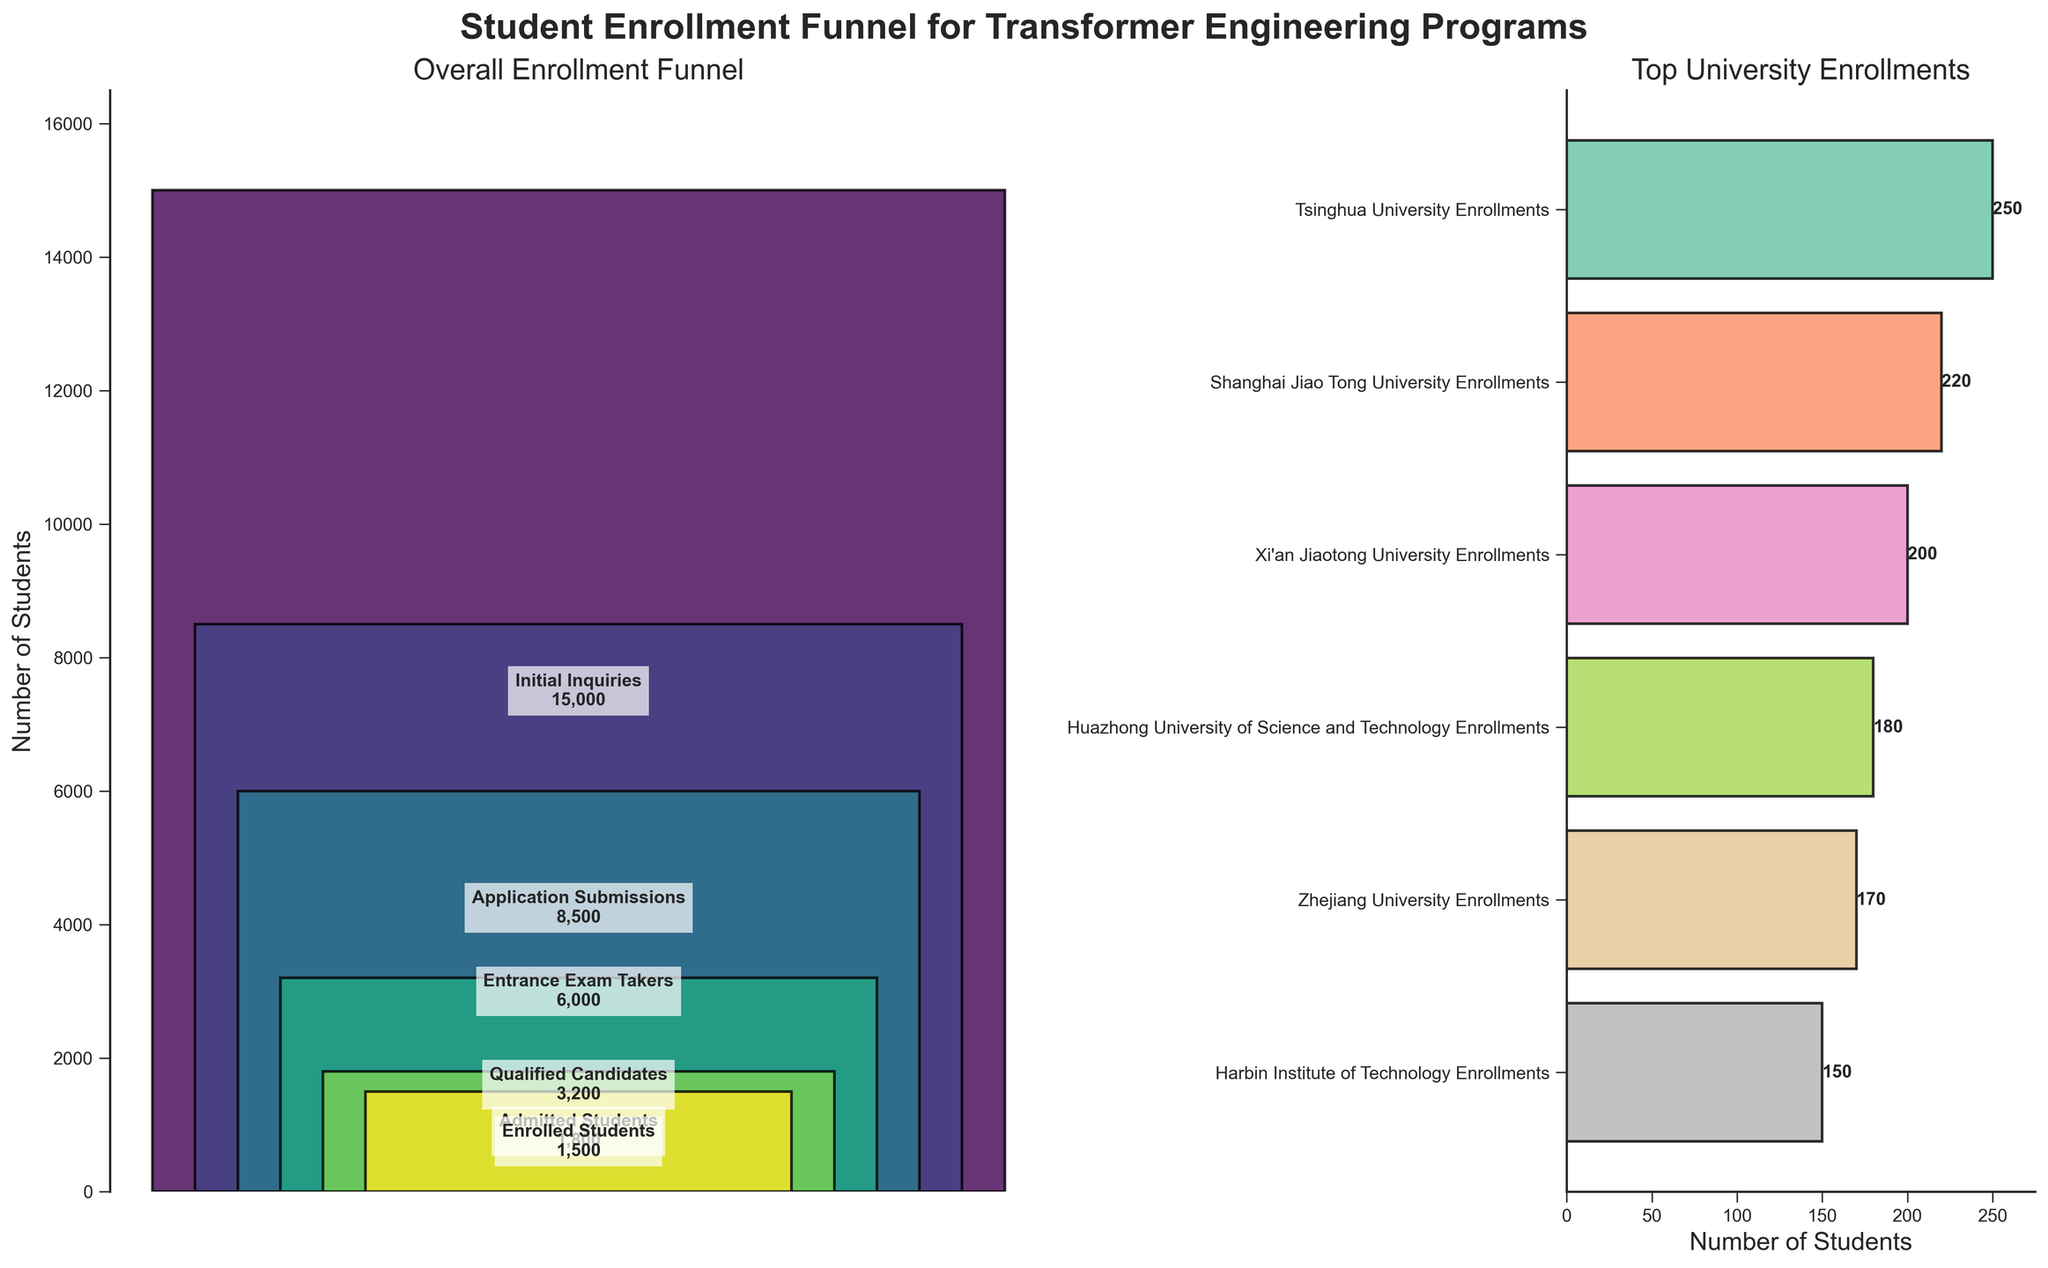What is the title of the figure? The title of the figure is displayed at the top and reads 'Student Enrollment Funnel for Transformer Engineering Programs'. This can be seen in bold and large font, indicating it is the main title.
Answer: Student Enrollment Funnel for Transformer Engineering Programs How many students initially inquired about the transformer engineering programs? According to the first stage of the funnel, labeled 'Initial Inquiries', the number of students is given as 15,000. This value is visually apparent as the first and widest bar in the funnel chart.
Answer: 15,000 Which university has the highest number of enrolled students in transformer engineering programs? The bar chart shows university-specific enrollments on the right. The university with the highest bar is Tsinghua University, having an enrollment number of 250 students, clearly labeled next to the bar.
Answer: Tsinghua University What is the total enrollment across the top universities? Summing up the enrollment numbers for the universities shown:
Tsinghua University: 250
Shanghai Jiao Tong University: 220
Xi'an Jiaotong University: 200
Huazhong University of Science and Technology: 180
Zhejiang University: 170
Harbin Institute of Technology: 150
Total = 250 + 220 + 200 + 180 + 170 + 150 = 1170
Answer: 1170 Compare the enrollment numbers between Huazhong University of Science and Technology and Zhejiang University. Which one is higher and by how much? Huazhong University of Science and Technology has 180 students, whereas Zhejiang University has 170 students enrolled. The difference is 180 - 170 = 10 students, with Huazhong having the higher number.
Answer: Huazhong University of Science and Technology by 10 students What percentage of students who took the entrance exam were admitted? The number of Entrance Exam Takers is 6000, and the number of Admitted Students is 1800. The percentage can be calculated as (1800 / 6000) * 100 = 30%.
Answer: 30% How many more students submitted applications compared to the number of students who were admitted? The number of Application Submissions is 8500, and the number of Admitted Students is 1800. The difference is 8500 - 1800 = 6700.
Answer: 6700 What is the ratio of enrolled students to qualified candidates? The number of Enrolled Students is 1500, and the number of Qualified Candidates is 3200. The ratio is 1500:3200, which simplifies to 15:32.
Answer: 15:32 